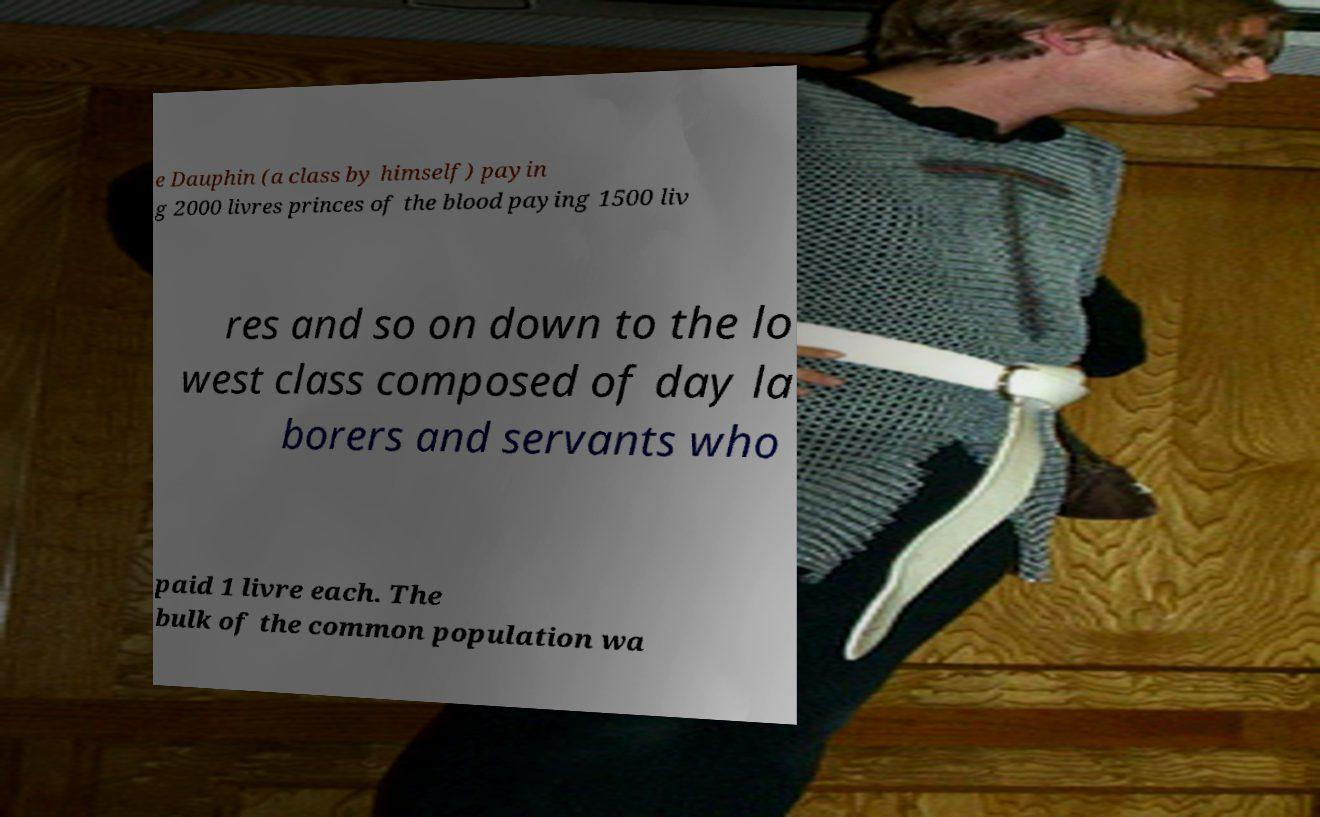There's text embedded in this image that I need extracted. Can you transcribe it verbatim? e Dauphin (a class by himself) payin g 2000 livres princes of the blood paying 1500 liv res and so on down to the lo west class composed of day la borers and servants who paid 1 livre each. The bulk of the common population wa 